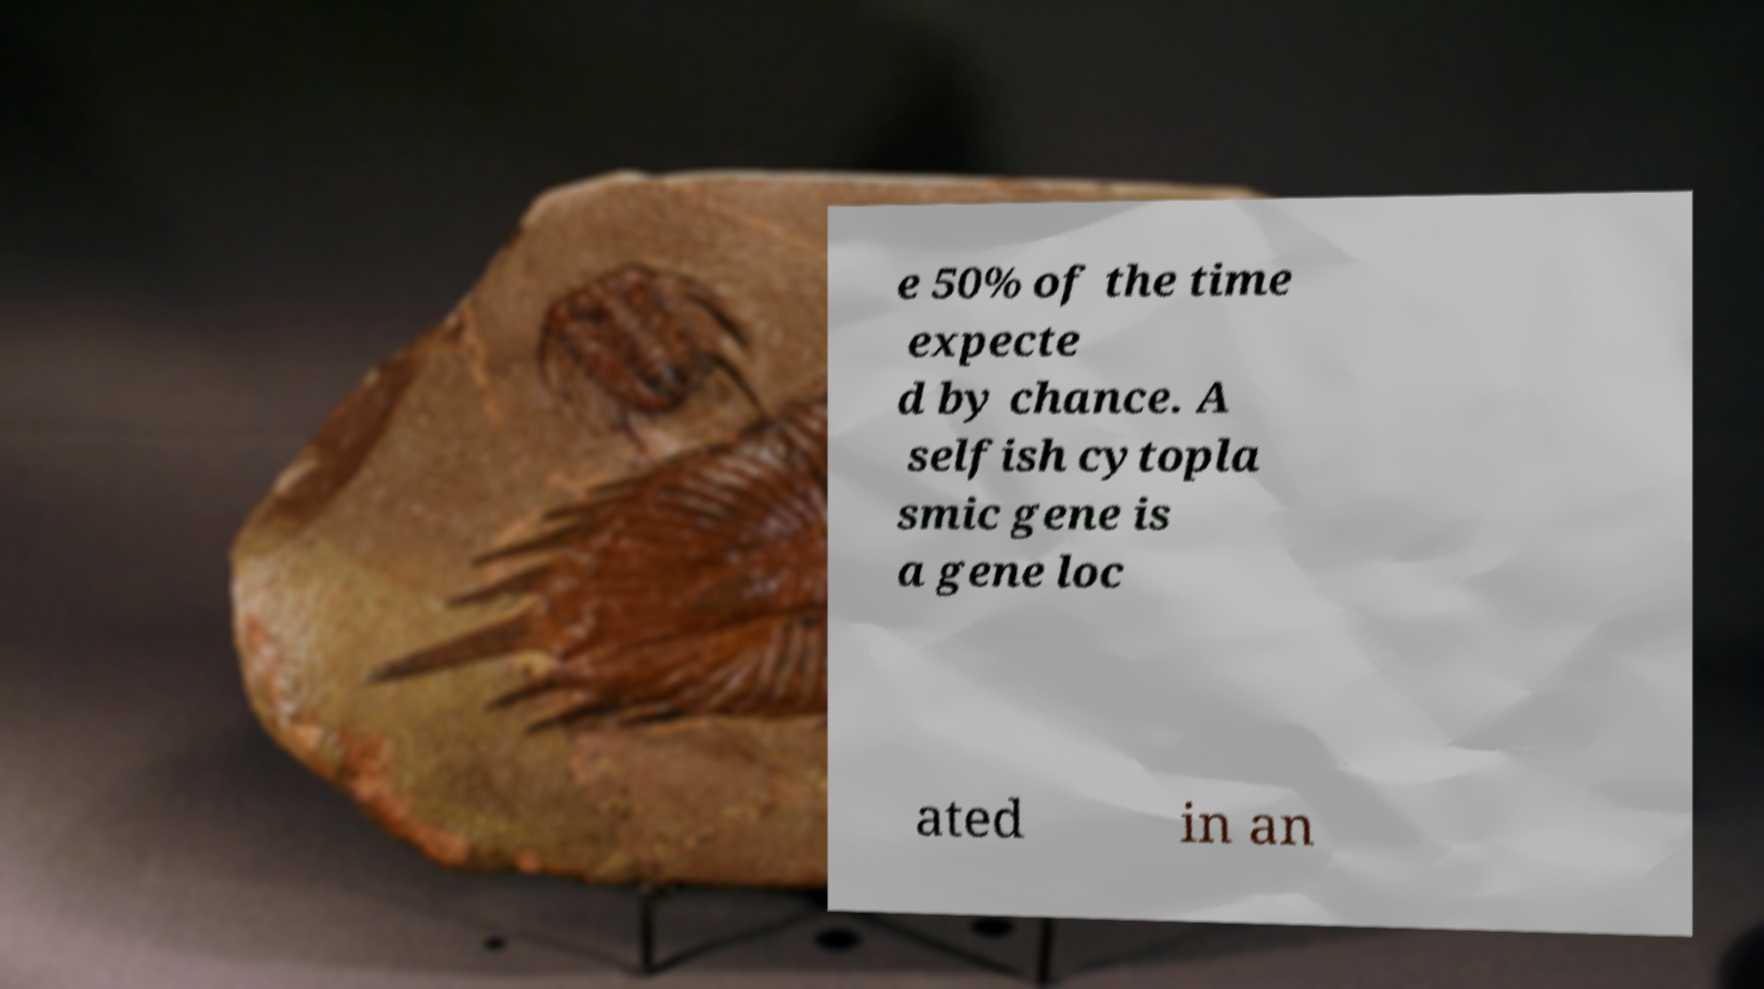What messages or text are displayed in this image? I need them in a readable, typed format. e 50% of the time expecte d by chance. A selfish cytopla smic gene is a gene loc ated in an 